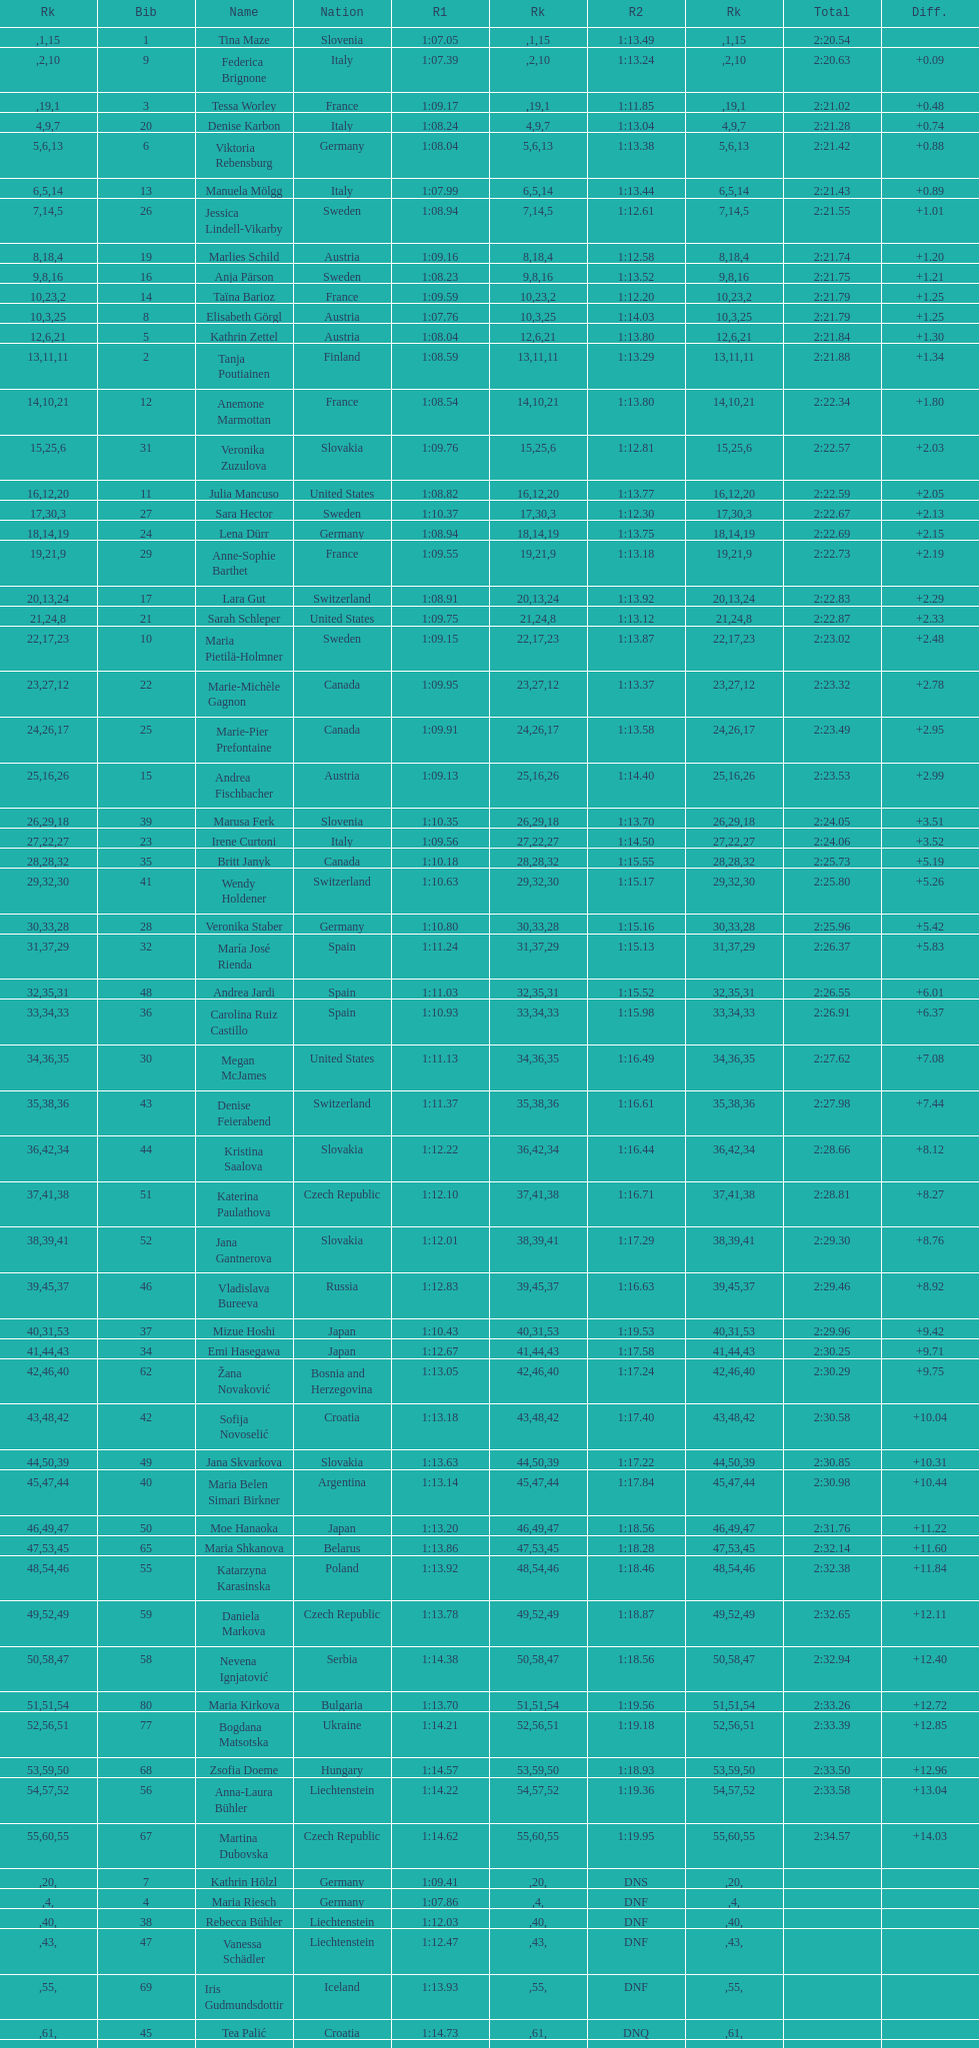Who finished next after federica brignone? Tessa Worley. 